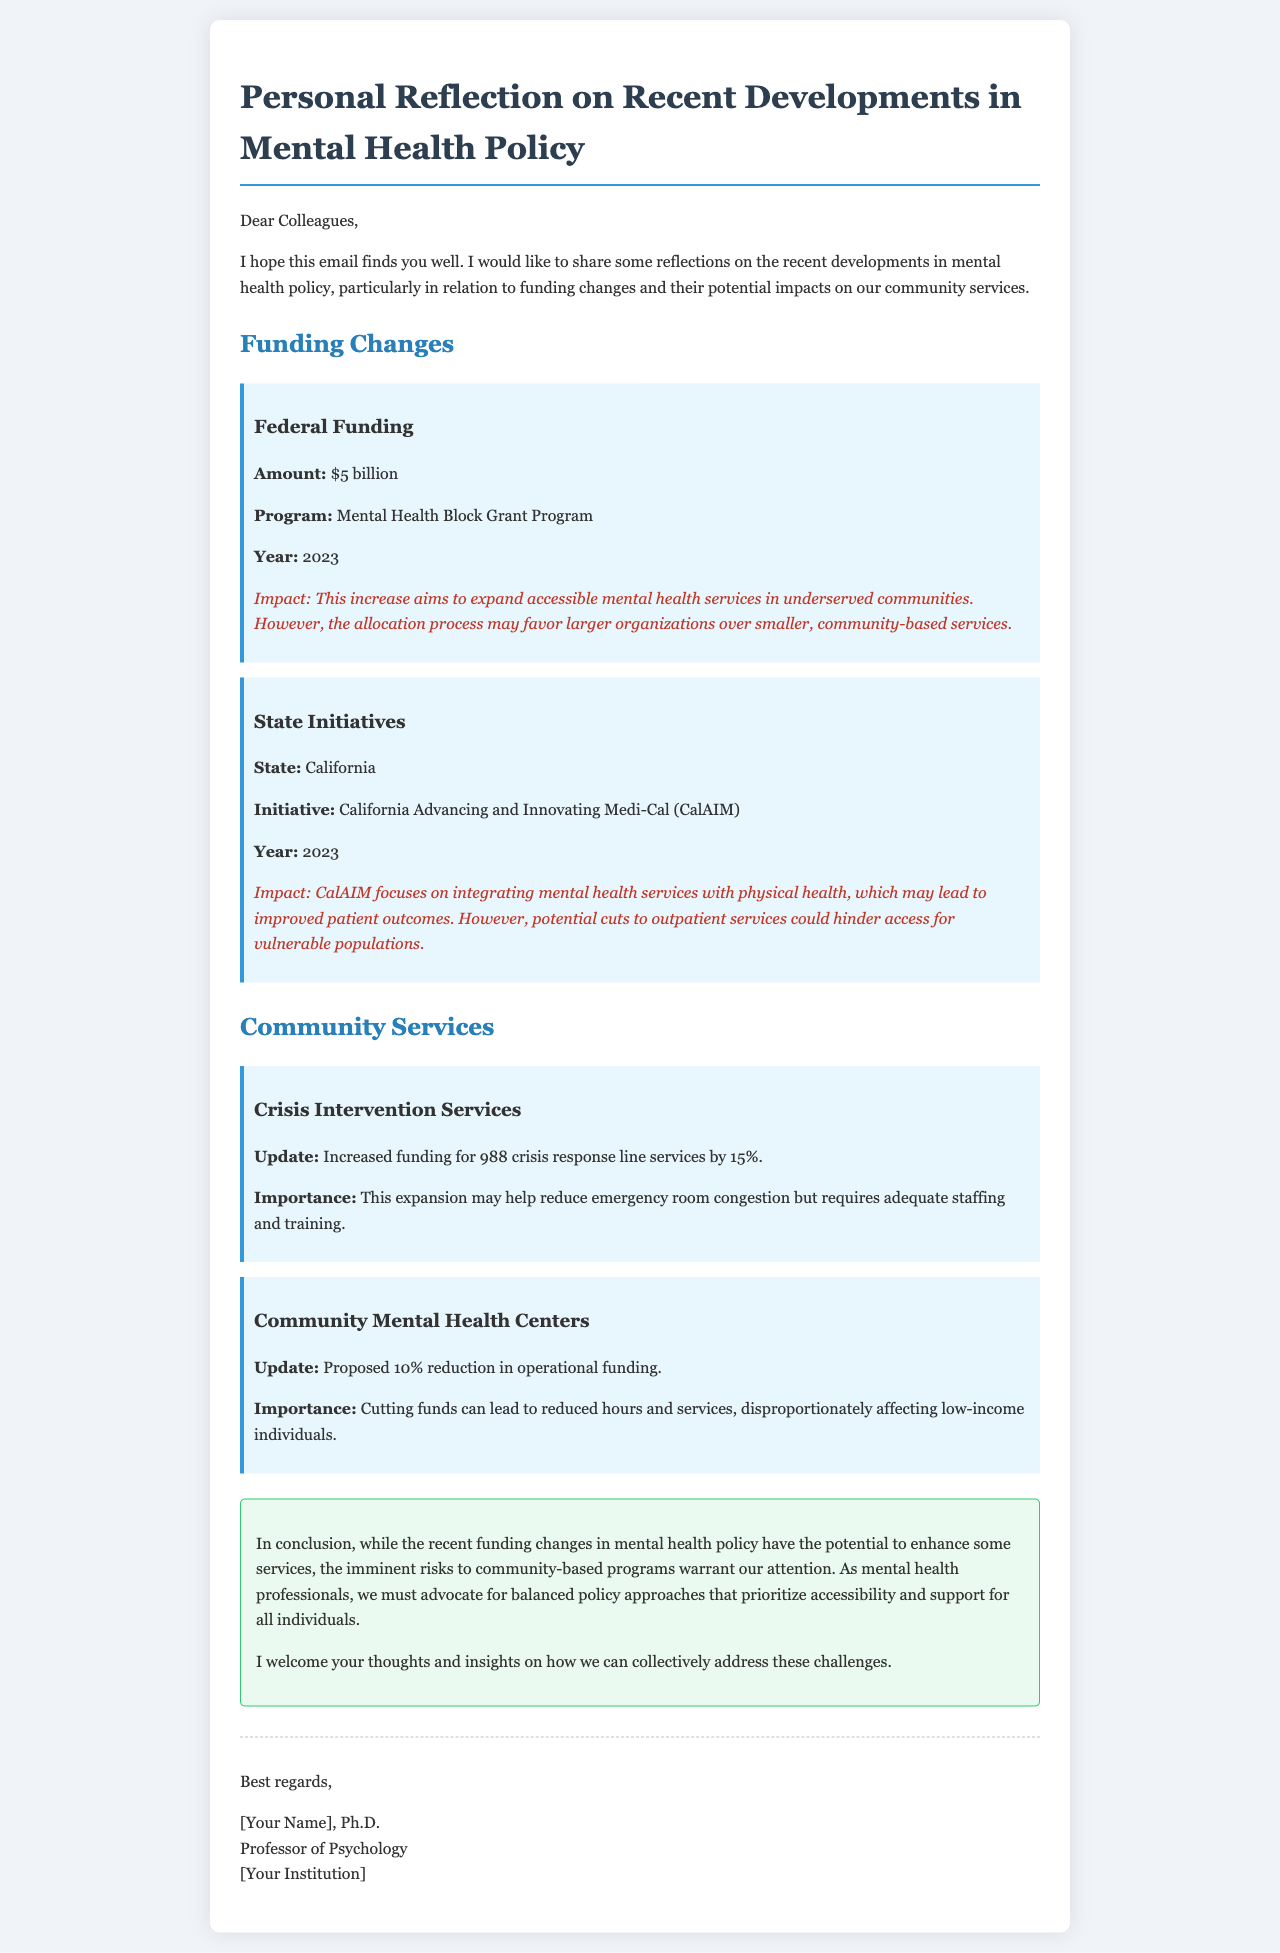What is the amount of federal funding mentioned? The document states that the federal funding amount is specified under the Federal Funding section, which is $5 billion.
Answer: $5 billion What is the year of the California initiative? The document mentions that the California initiative, CalAIM, took place in 2023, as noted in the State Initiatives section.
Answer: 2023 What is the proposed reduction percentage for community mental health center funding? The proposed reduction in operational funding for community mental health centers is stated in the document as 10%, found in the Community Mental Health Centers section.
Answer: 10% What service's funding was increased by 15%? The document highlights that the 988 crisis response line services funding was increased by 15%, detailed in the Crisis Intervention Services section.
Answer: 988 crisis response line services What potential issue may arise from the increased federal funding? The document points out that the allocation process for federal funding may favor larger organizations over smaller, community-based services, indicating a concern found under Federal Funding.
Answer: Favoring larger organizations What is the impact of the CalAIM initiative? The document describes that the CalAIM initiative focuses on integrating mental health services with physical health, which may lead to improved patient outcomes, as mentioned in State Initiatives.
Answer: Improved patient outcomes What is the conclusion of the email? The conclusion summarizes that while funding changes have the potential to enhance services, risks to community-based programs warrant attention, as indicated in the conclusion section.
Answer: Risks to community-based programs What signature is included in the email? The document mentions the signature includes the sender's name, title, and institution, formatted in the signature section.
Answer: [Your Name], Ph.D 